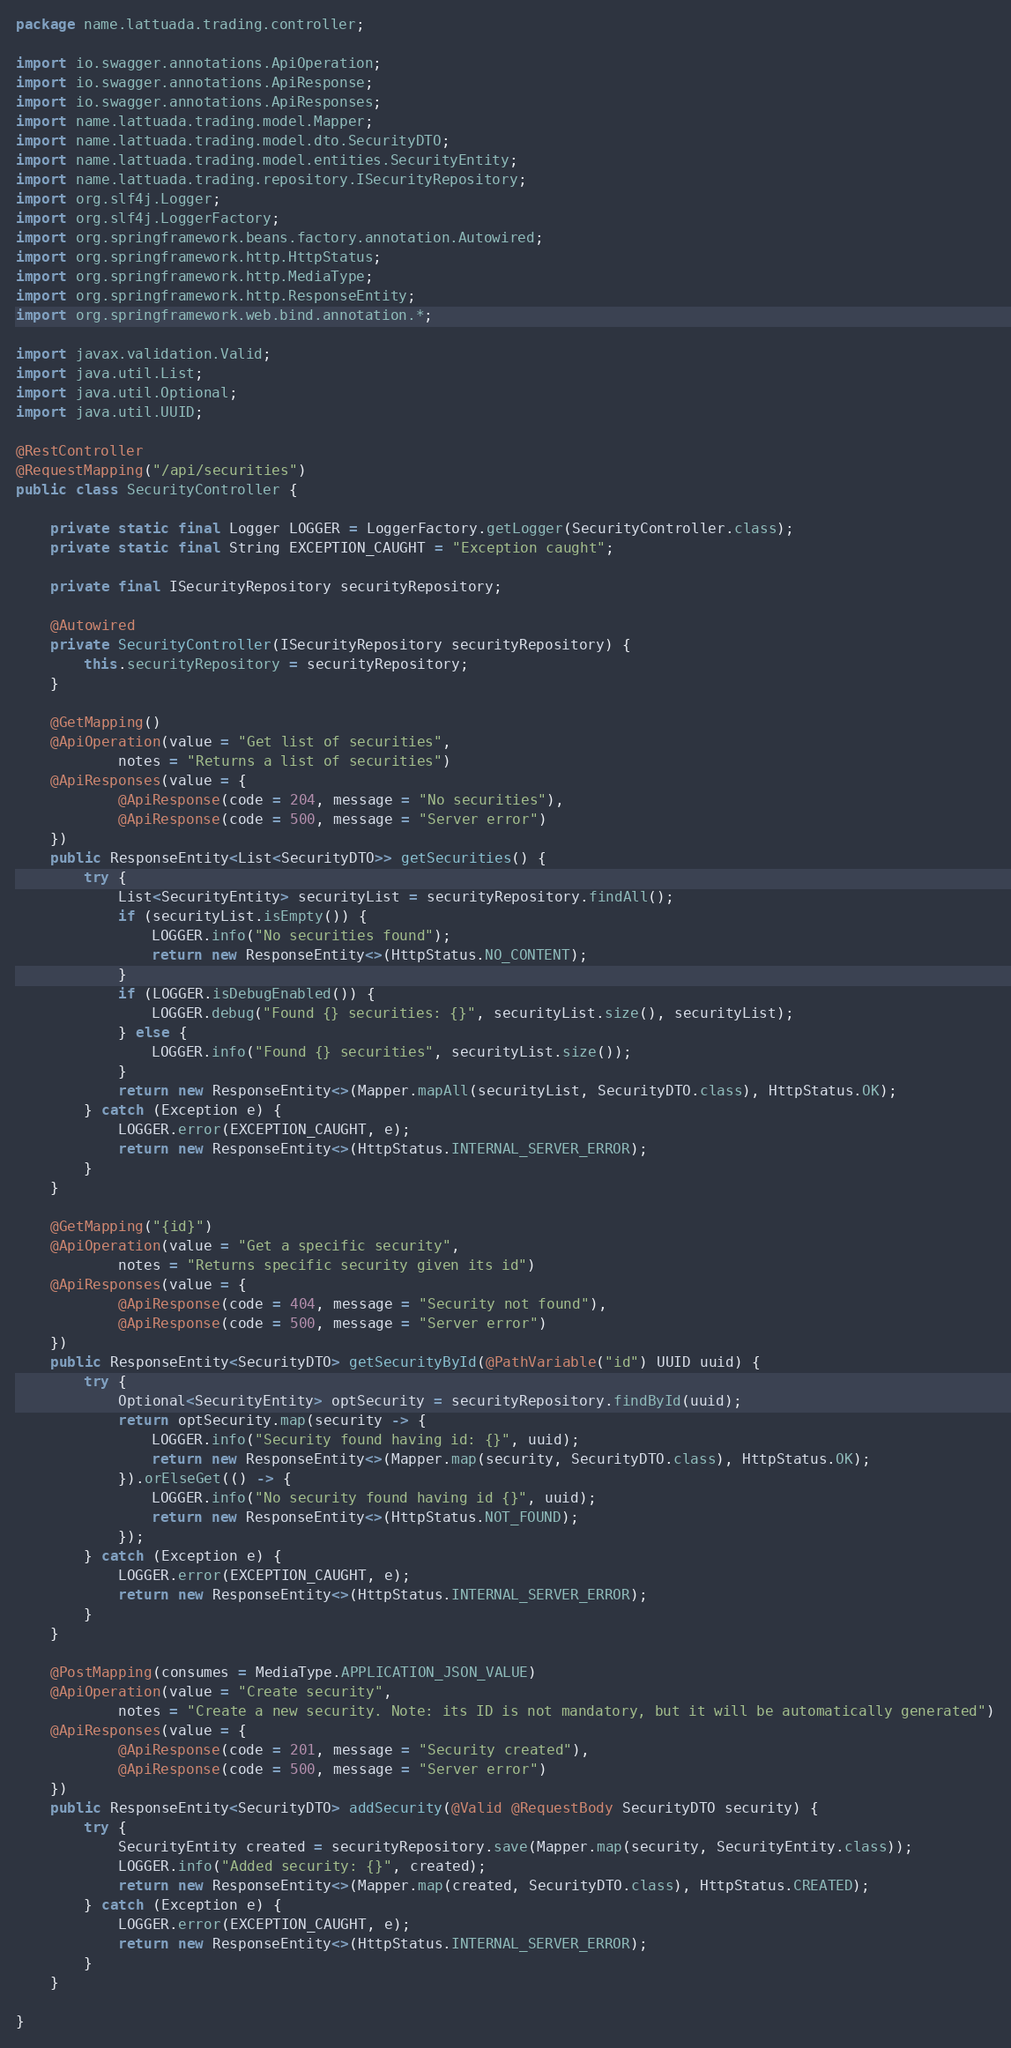<code> <loc_0><loc_0><loc_500><loc_500><_Java_>package name.lattuada.trading.controller;

import io.swagger.annotations.ApiOperation;
import io.swagger.annotations.ApiResponse;
import io.swagger.annotations.ApiResponses;
import name.lattuada.trading.model.Mapper;
import name.lattuada.trading.model.dto.SecurityDTO;
import name.lattuada.trading.model.entities.SecurityEntity;
import name.lattuada.trading.repository.ISecurityRepository;
import org.slf4j.Logger;
import org.slf4j.LoggerFactory;
import org.springframework.beans.factory.annotation.Autowired;
import org.springframework.http.HttpStatus;
import org.springframework.http.MediaType;
import org.springframework.http.ResponseEntity;
import org.springframework.web.bind.annotation.*;

import javax.validation.Valid;
import java.util.List;
import java.util.Optional;
import java.util.UUID;

@RestController
@RequestMapping("/api/securities")
public class SecurityController {

    private static final Logger LOGGER = LoggerFactory.getLogger(SecurityController.class);
    private static final String EXCEPTION_CAUGHT = "Exception caught";

    private final ISecurityRepository securityRepository;

    @Autowired
    private SecurityController(ISecurityRepository securityRepository) {
        this.securityRepository = securityRepository;
    }

    @GetMapping()
    @ApiOperation(value = "Get list of securities",
            notes = "Returns a list of securities")
    @ApiResponses(value = {
            @ApiResponse(code = 204, message = "No securities"),
            @ApiResponse(code = 500, message = "Server error")
    })
    public ResponseEntity<List<SecurityDTO>> getSecurities() {
        try {
            List<SecurityEntity> securityList = securityRepository.findAll();
            if (securityList.isEmpty()) {
                LOGGER.info("No securities found");
                return new ResponseEntity<>(HttpStatus.NO_CONTENT);
            }
            if (LOGGER.isDebugEnabled()) {
                LOGGER.debug("Found {} securities: {}", securityList.size(), securityList);
            } else {
                LOGGER.info("Found {} securities", securityList.size());
            }
            return new ResponseEntity<>(Mapper.mapAll(securityList, SecurityDTO.class), HttpStatus.OK);
        } catch (Exception e) {
            LOGGER.error(EXCEPTION_CAUGHT, e);
            return new ResponseEntity<>(HttpStatus.INTERNAL_SERVER_ERROR);
        }
    }

    @GetMapping("{id}")
    @ApiOperation(value = "Get a specific security",
            notes = "Returns specific security given its id")
    @ApiResponses(value = {
            @ApiResponse(code = 404, message = "Security not found"),
            @ApiResponse(code = 500, message = "Server error")
    })
    public ResponseEntity<SecurityDTO> getSecurityById(@PathVariable("id") UUID uuid) {
        try {
            Optional<SecurityEntity> optSecurity = securityRepository.findById(uuid);
            return optSecurity.map(security -> {
                LOGGER.info("Security found having id: {}", uuid);
                return new ResponseEntity<>(Mapper.map(security, SecurityDTO.class), HttpStatus.OK);
            }).orElseGet(() -> {
                LOGGER.info("No security found having id {}", uuid);
                return new ResponseEntity<>(HttpStatus.NOT_FOUND);
            });
        } catch (Exception e) {
            LOGGER.error(EXCEPTION_CAUGHT, e);
            return new ResponseEntity<>(HttpStatus.INTERNAL_SERVER_ERROR);
        }
    }

    @PostMapping(consumes = MediaType.APPLICATION_JSON_VALUE)
    @ApiOperation(value = "Create security",
            notes = "Create a new security. Note: its ID is not mandatory, but it will be automatically generated")
    @ApiResponses(value = {
            @ApiResponse(code = 201, message = "Security created"),
            @ApiResponse(code = 500, message = "Server error")
    })
    public ResponseEntity<SecurityDTO> addSecurity(@Valid @RequestBody SecurityDTO security) {
        try {
            SecurityEntity created = securityRepository.save(Mapper.map(security, SecurityEntity.class));
            LOGGER.info("Added security: {}", created);
            return new ResponseEntity<>(Mapper.map(created, SecurityDTO.class), HttpStatus.CREATED);
        } catch (Exception e) {
            LOGGER.error(EXCEPTION_CAUGHT, e);
            return new ResponseEntity<>(HttpStatus.INTERNAL_SERVER_ERROR);
        }
    }

}
</code> 